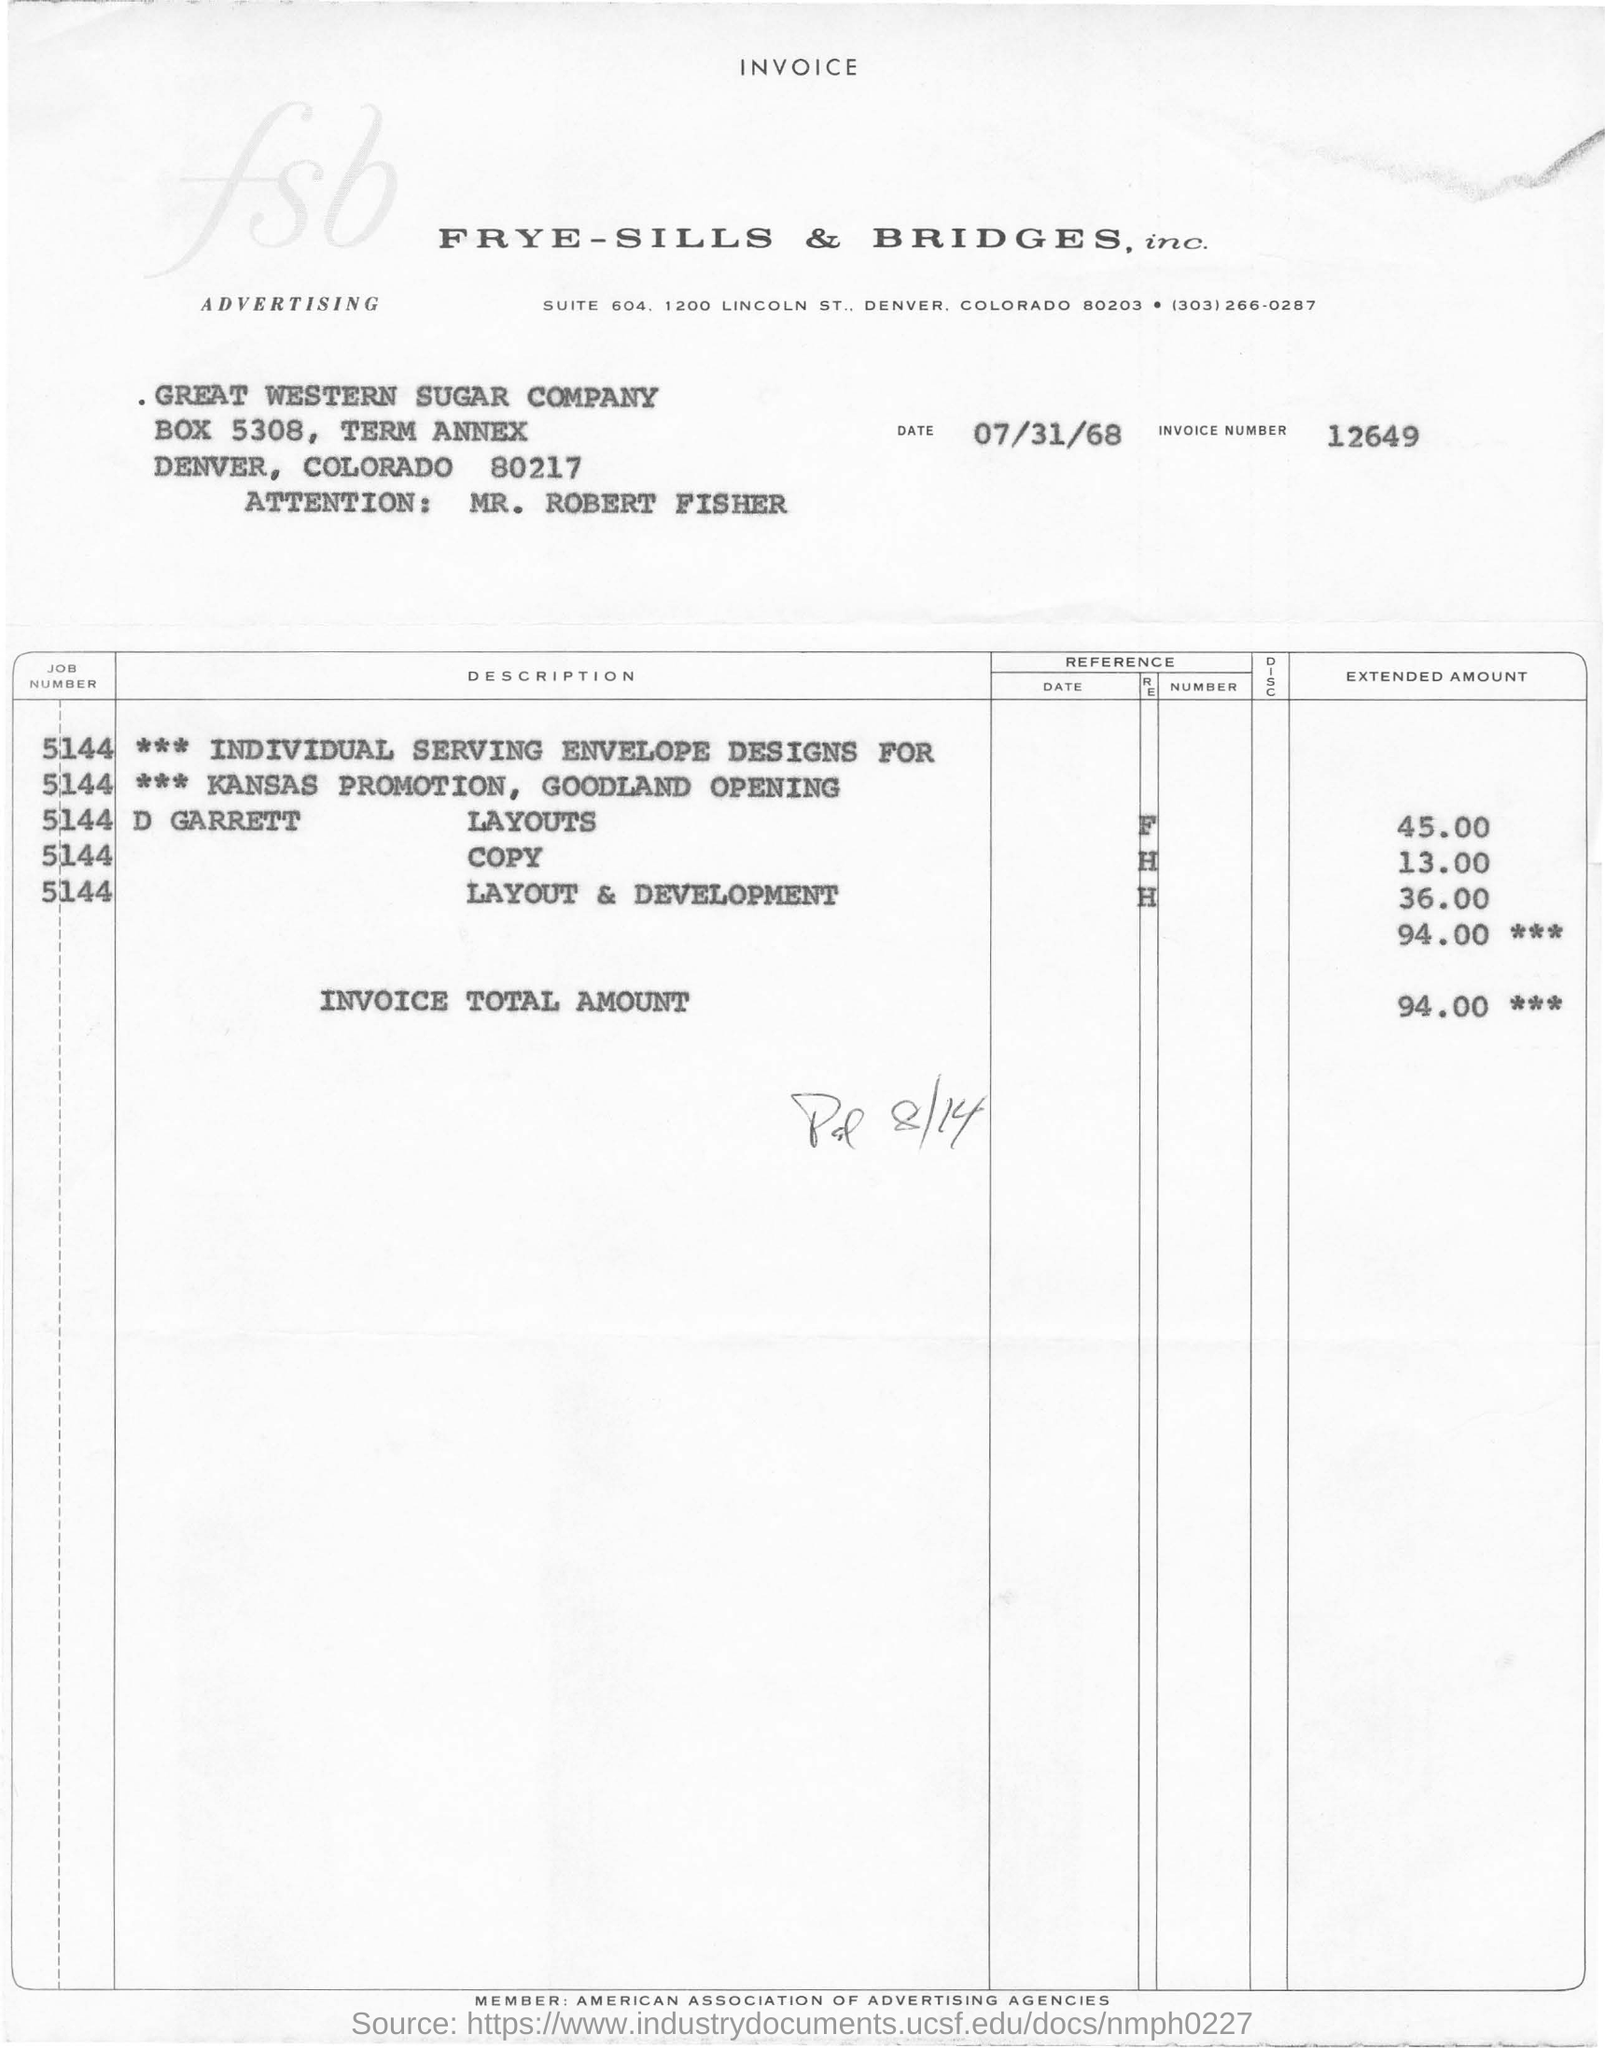Give some essential details in this illustration. What is the invoice number given? It is 12649. The company responsible for raising the invoice is FRYE-SILLS & BRIDGES, inc. The total amount of the invoice is 94 dollars. The invoice number is 12649. 